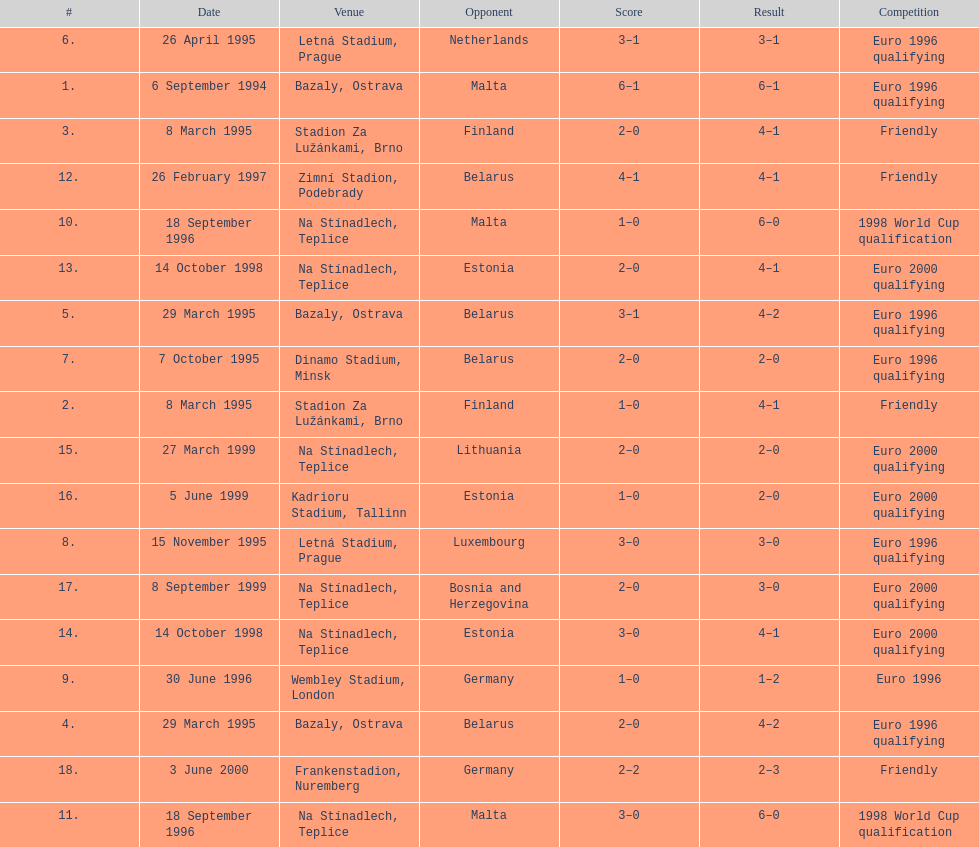What was the number of times czech republic played against germany? 2. Could you parse the entire table as a dict? {'header': ['#', 'Date', 'Venue', 'Opponent', 'Score', 'Result', 'Competition'], 'rows': [['6.', '26 April 1995', 'Letná Stadium, Prague', 'Netherlands', '3–1', '3–1', 'Euro 1996 qualifying'], ['1.', '6 September 1994', 'Bazaly, Ostrava', 'Malta', '6–1', '6–1', 'Euro 1996 qualifying'], ['3.', '8 March 1995', 'Stadion Za Lužánkami, Brno', 'Finland', '2–0', '4–1', 'Friendly'], ['12.', '26 February 1997', 'Zimní Stadion, Podebrady', 'Belarus', '4–1', '4–1', 'Friendly'], ['10.', '18 September 1996', 'Na Stínadlech, Teplice', 'Malta', '1–0', '6–0', '1998 World Cup qualification'], ['13.', '14 October 1998', 'Na Stínadlech, Teplice', 'Estonia', '2–0', '4–1', 'Euro 2000 qualifying'], ['5.', '29 March 1995', 'Bazaly, Ostrava', 'Belarus', '3–1', '4–2', 'Euro 1996 qualifying'], ['7.', '7 October 1995', 'Dinamo Stadium, Minsk', 'Belarus', '2–0', '2–0', 'Euro 1996 qualifying'], ['2.', '8 March 1995', 'Stadion Za Lužánkami, Brno', 'Finland', '1–0', '4–1', 'Friendly'], ['15.', '27 March 1999', 'Na Stínadlech, Teplice', 'Lithuania', '2–0', '2–0', 'Euro 2000 qualifying'], ['16.', '5 June 1999', 'Kadrioru Stadium, Tallinn', 'Estonia', '1–0', '2–0', 'Euro 2000 qualifying'], ['8.', '15 November 1995', 'Letná Stadium, Prague', 'Luxembourg', '3–0', '3–0', 'Euro 1996 qualifying'], ['17.', '8 September 1999', 'Na Stínadlech, Teplice', 'Bosnia and Herzegovina', '2–0', '3–0', 'Euro 2000 qualifying'], ['14.', '14 October 1998', 'Na Stínadlech, Teplice', 'Estonia', '3–0', '4–1', 'Euro 2000 qualifying'], ['9.', '30 June 1996', 'Wembley Stadium, London', 'Germany', '1–0', '1–2', 'Euro 1996'], ['4.', '29 March 1995', 'Bazaly, Ostrava', 'Belarus', '2–0', '4–2', 'Euro 1996 qualifying'], ['18.', '3 June 2000', 'Frankenstadion, Nuremberg', 'Germany', '2–2', '2–3', 'Friendly'], ['11.', '18 September 1996', 'Na Stínadlech, Teplice', 'Malta', '3–0', '6–0', '1998 World Cup qualification']]} 